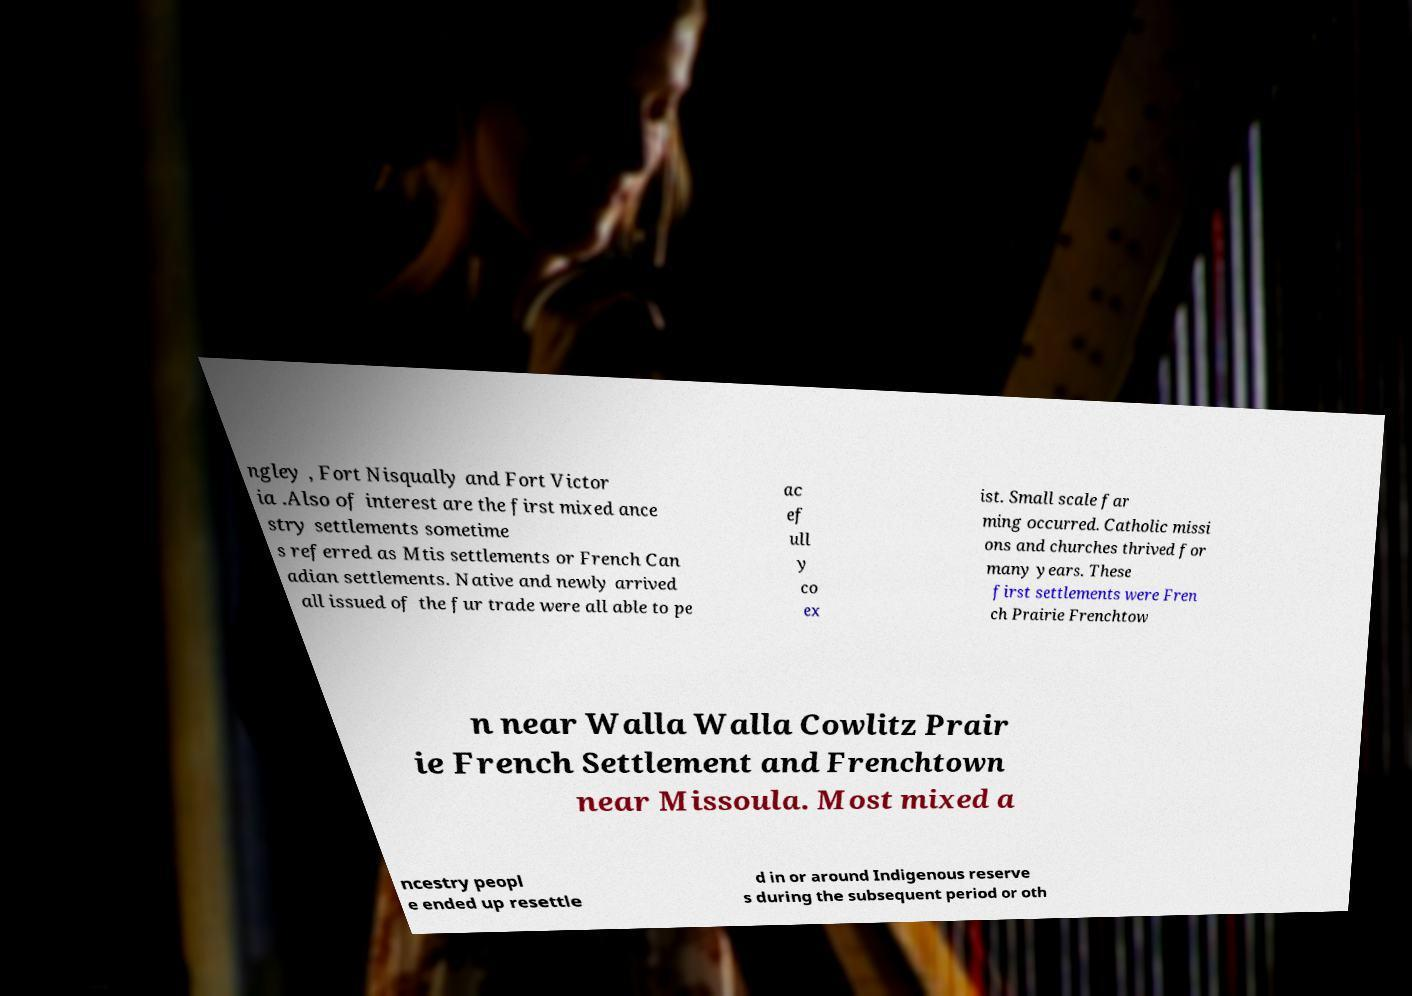What messages or text are displayed in this image? I need them in a readable, typed format. ngley , Fort Nisqually and Fort Victor ia .Also of interest are the first mixed ance stry settlements sometime s referred as Mtis settlements or French Can adian settlements. Native and newly arrived all issued of the fur trade were all able to pe ac ef ull y co ex ist. Small scale far ming occurred. Catholic missi ons and churches thrived for many years. These first settlements were Fren ch Prairie Frenchtow n near Walla Walla Cowlitz Prair ie French Settlement and Frenchtown near Missoula. Most mixed a ncestry peopl e ended up resettle d in or around Indigenous reserve s during the subsequent period or oth 